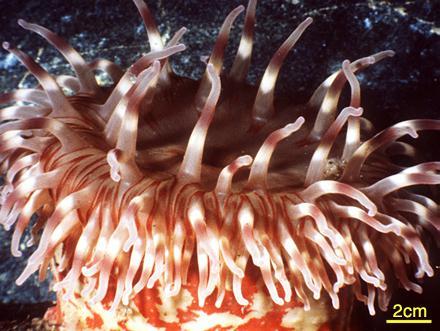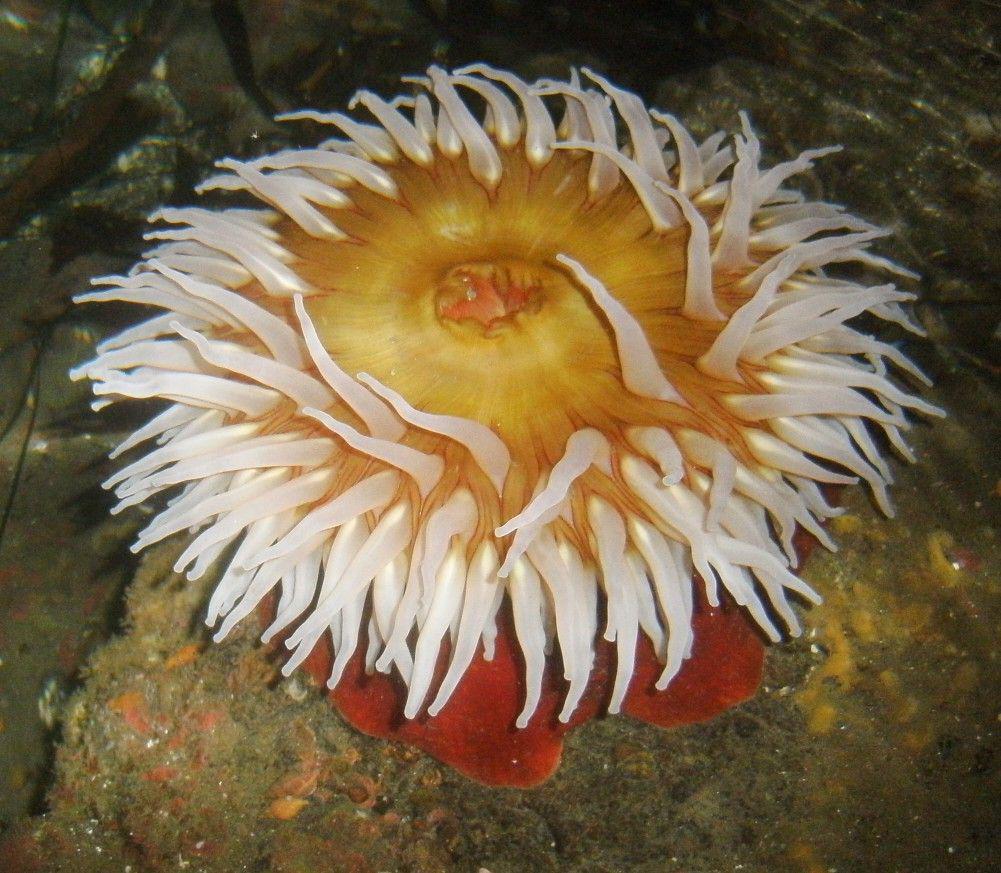The first image is the image on the left, the second image is the image on the right. Given the left and right images, does the statement "The base of the anemone is red in the image on the right." hold true? Answer yes or no. Yes. The first image is the image on the left, the second image is the image on the right. Assess this claim about the two images: "At least one of the images shows more than one anemone.". Correct or not? Answer yes or no. No. 